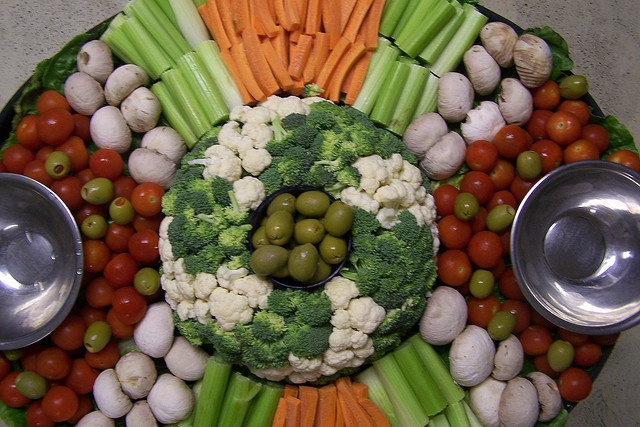Describe the objects in this image and their specific colors. I can see dining table in black, gray, maroon, darkgray, and darkgreen tones, bowl in gray, black, and lightgray tones, carrot in gray, red, orange, and salmon tones, bowl in gray, black, and darkgray tones, and broccoli in gray, darkgreen, and black tones in this image. 